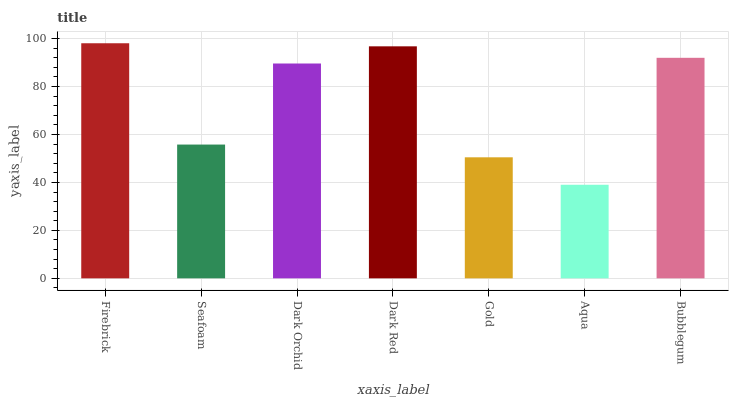Is Aqua the minimum?
Answer yes or no. Yes. Is Firebrick the maximum?
Answer yes or no. Yes. Is Seafoam the minimum?
Answer yes or no. No. Is Seafoam the maximum?
Answer yes or no. No. Is Firebrick greater than Seafoam?
Answer yes or no. Yes. Is Seafoam less than Firebrick?
Answer yes or no. Yes. Is Seafoam greater than Firebrick?
Answer yes or no. No. Is Firebrick less than Seafoam?
Answer yes or no. No. Is Dark Orchid the high median?
Answer yes or no. Yes. Is Dark Orchid the low median?
Answer yes or no. Yes. Is Bubblegum the high median?
Answer yes or no. No. Is Firebrick the low median?
Answer yes or no. No. 